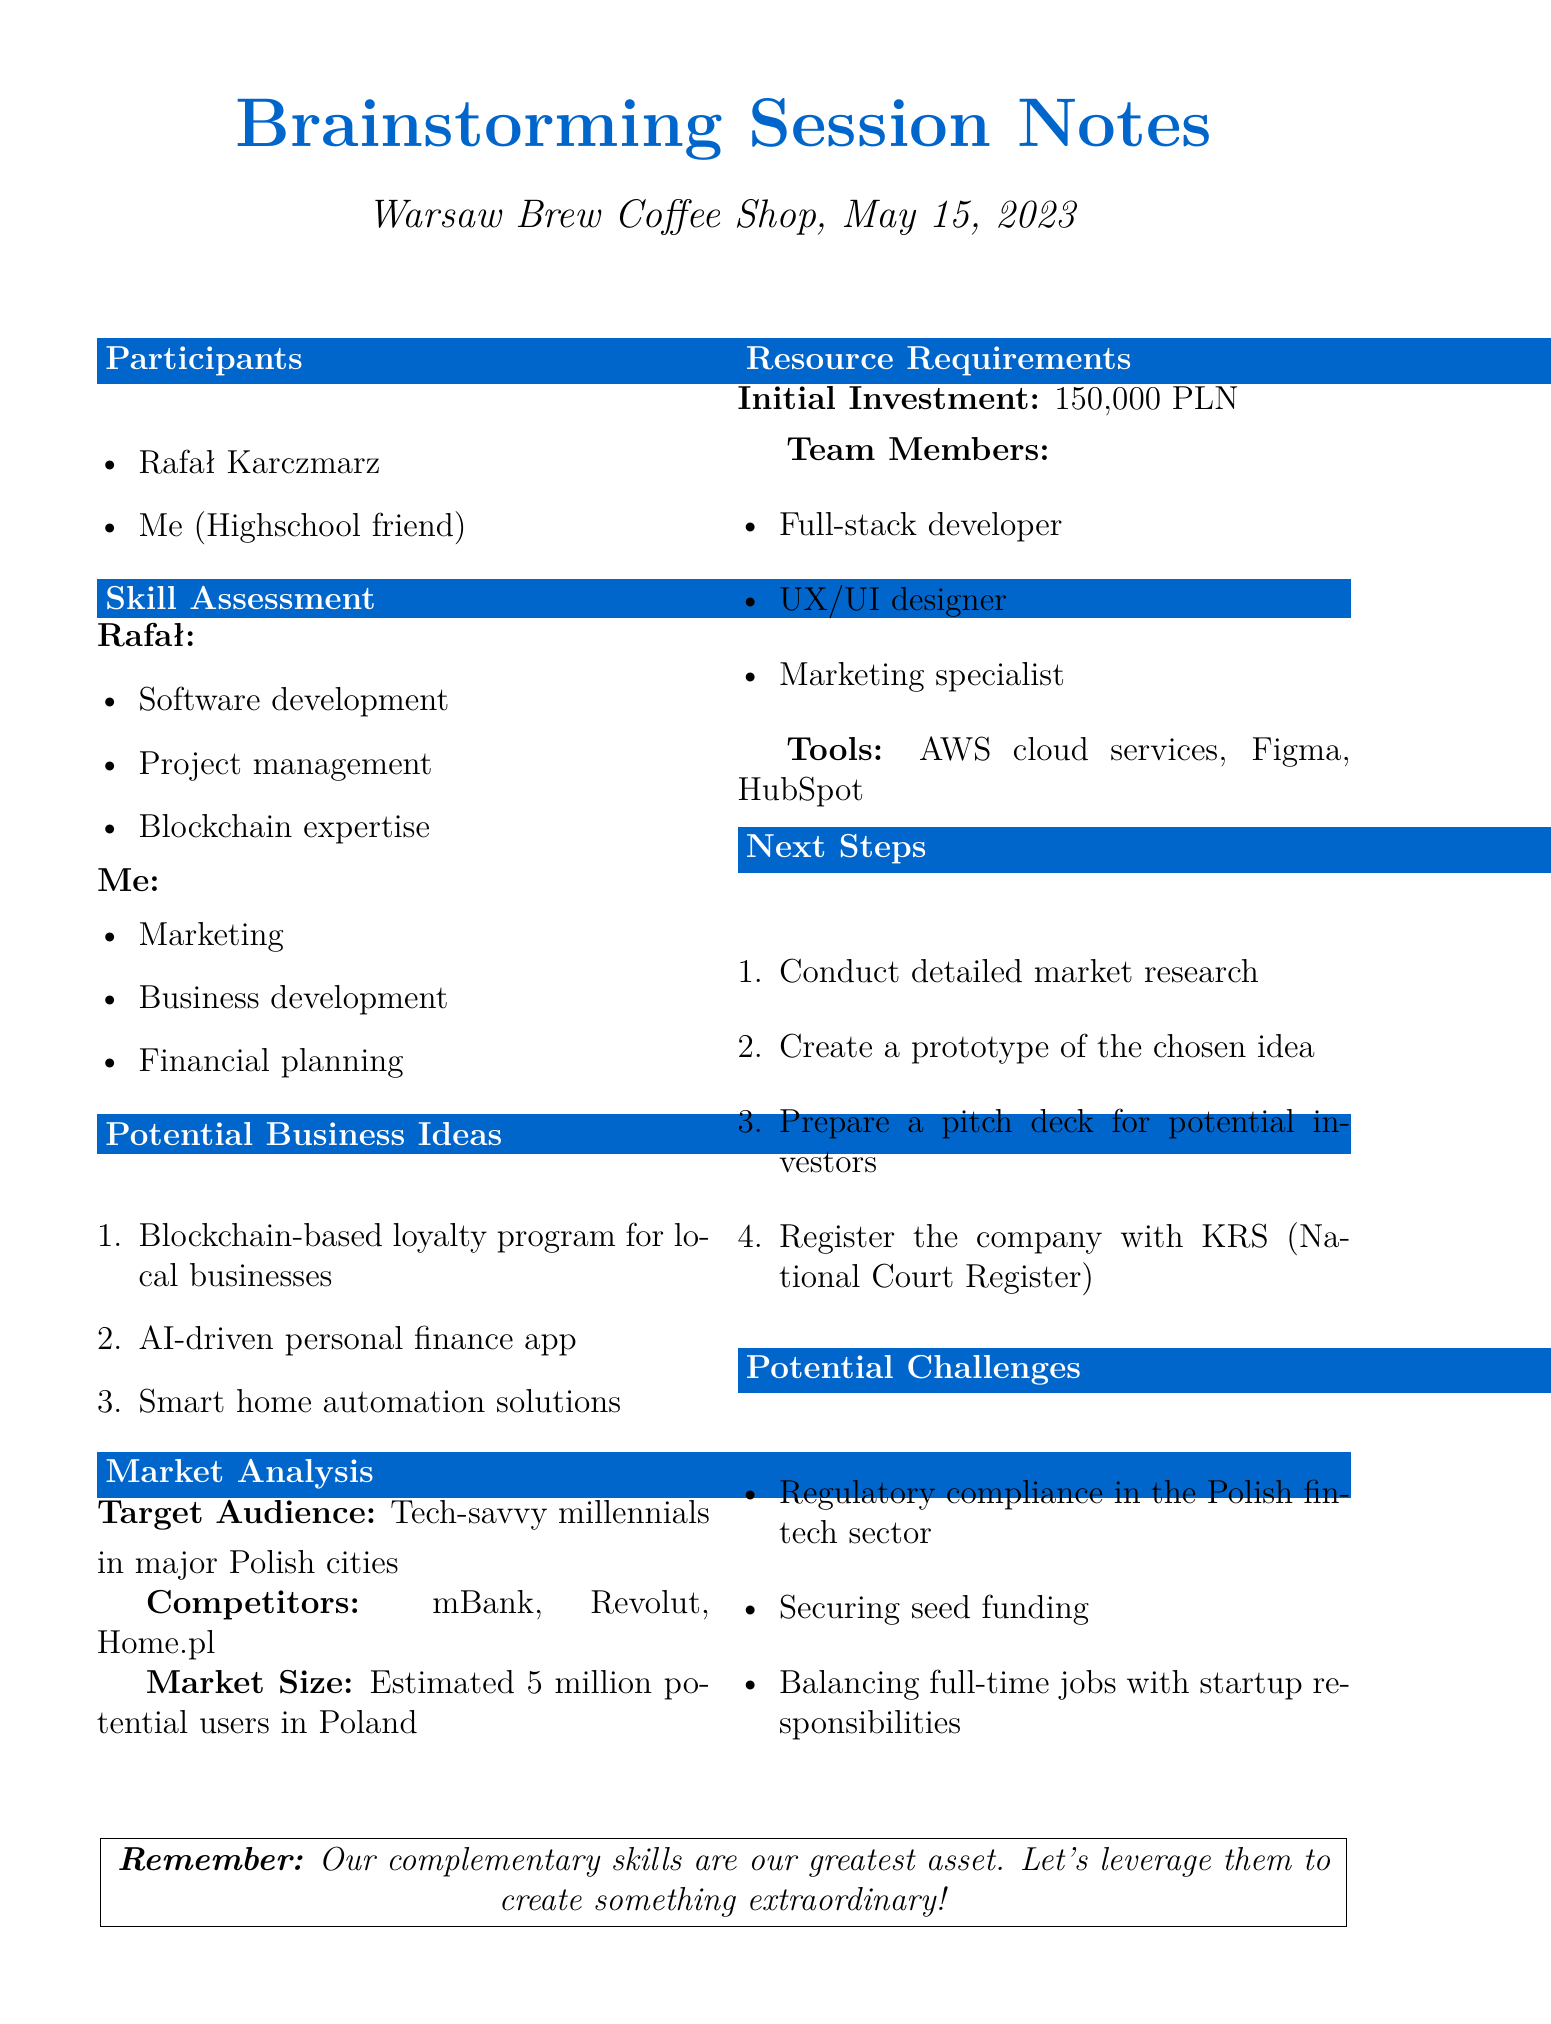What was the date of the meeting? The meeting was held on May 15, 2023, as indicated in the document.
Answer: May 15, 2023 Where did the brainstorming session take place? The location of the meeting is specified as Warsaw Brew Coffee Shop in the document.
Answer: Warsaw Brew Coffee Shop What is one skill that Rafał possesses? Rafał's skills listed in the document include software development, project management, and blockchain expertise.
Answer: Software development What is the estimated market size in Poland? The document states that the estimated market size is 5 million potential users in Poland.
Answer: 5 million What is one potential business idea discussed? The document lists several ideas, including a blockchain-based loyalty program, among others.
Answer: Blockchain-based loyalty program for local businesses What is the required initial investment for the business venture? The document specifies the initial investment requirement as 150,000 PLN.
Answer: 150,000 PLN Who are the competitors mentioned in the market analysis? The document lists mBank, Revolut, and Home.pl as competitors in the market analysis.
Answer: mBank, Revolut, Home.pl What is one potential challenge identified? The document outlines several challenges, one being regulatory compliance in the Polish fintech sector.
Answer: Regulatory compliance in the Polish fintech sector What is one of the next steps outlined in the document? The document suggests conducting detailed market research as one of the next steps to take.
Answer: Conduct detailed market research 